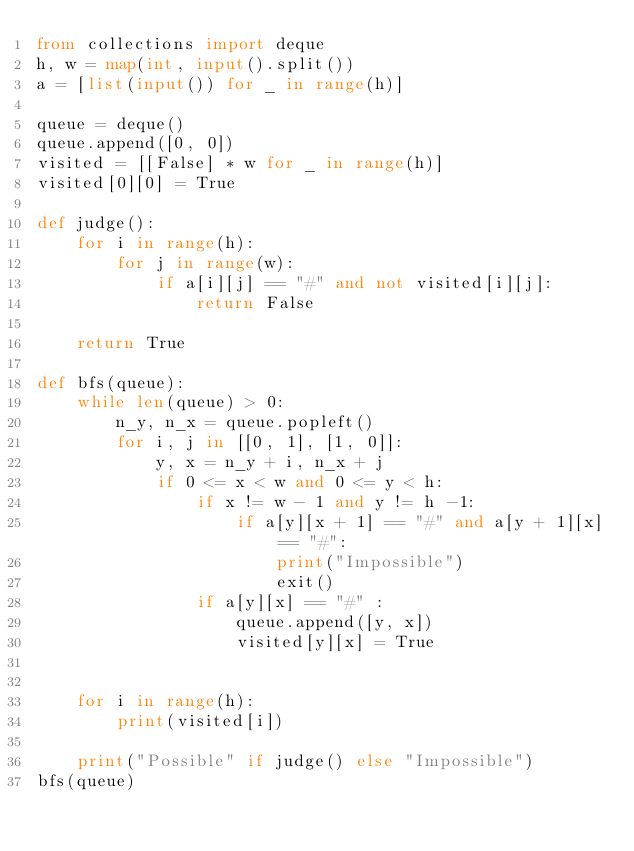Convert code to text. <code><loc_0><loc_0><loc_500><loc_500><_Python_>from collections import deque
h, w = map(int, input().split())
a = [list(input()) for _ in range(h)]

queue = deque()
queue.append([0, 0])
visited = [[False] * w for _ in range(h)]
visited[0][0] = True

def judge():
    for i in range(h):
        for j in range(w):
            if a[i][j] == "#" and not visited[i][j]:
                return False
    
    return True

def bfs(queue):
    while len(queue) > 0:
        n_y, n_x = queue.popleft()
        for i, j in [[0, 1], [1, 0]]:
            y, x = n_y + i, n_x + j
            if 0 <= x < w and 0 <= y < h:
                if x != w - 1 and y != h -1:
                    if a[y][x + 1] == "#" and a[y + 1][x] == "#":
                        print("Impossible")
                        exit()
                if a[y][x] == "#" :
                    queue.append([y, x])
                    visited[y][x] = True
    
    
    for i in range(h):
        print(visited[i])
    
    print("Possible" if judge() else "Impossible")
bfs(queue)
</code> 